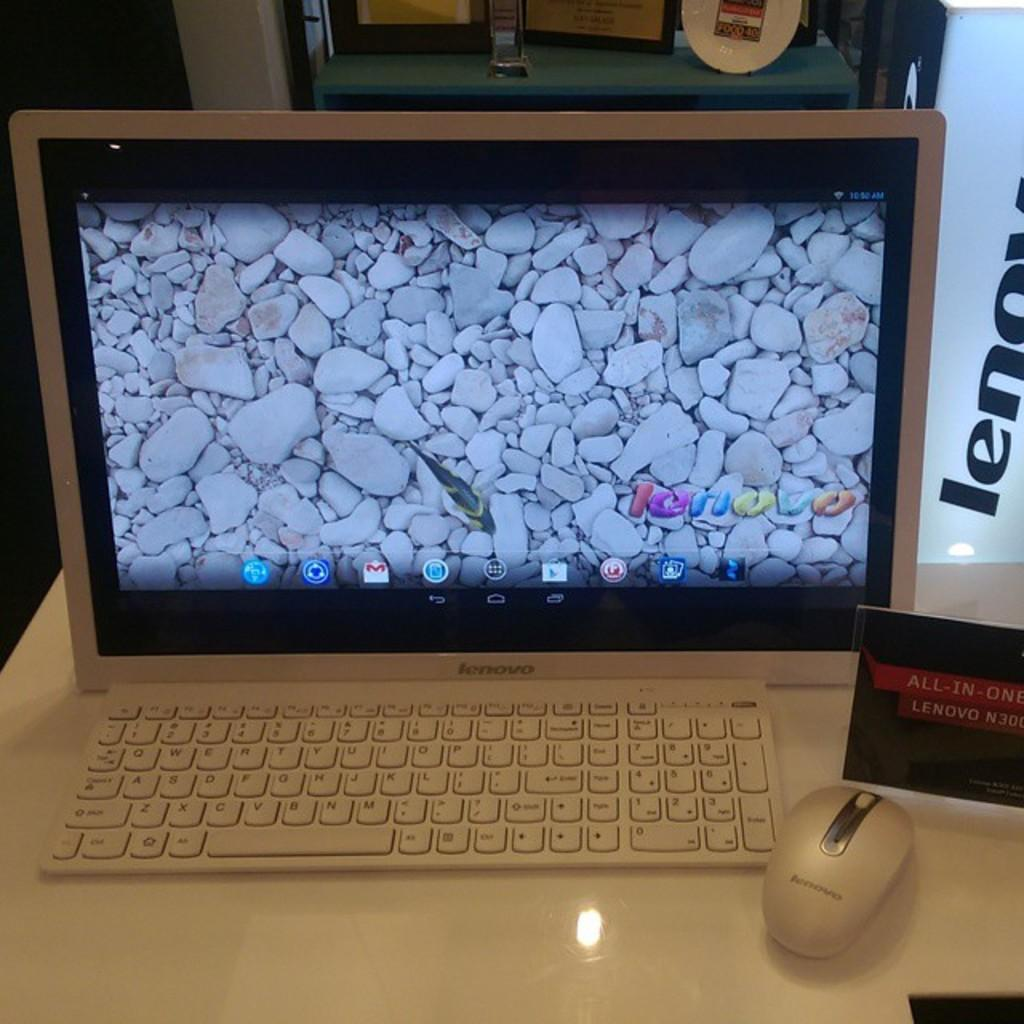Provide a one-sentence caption for the provided image. The Lenovo monitor displays what looks like the rocky bottom of a fish tank with a fish swimming by. 